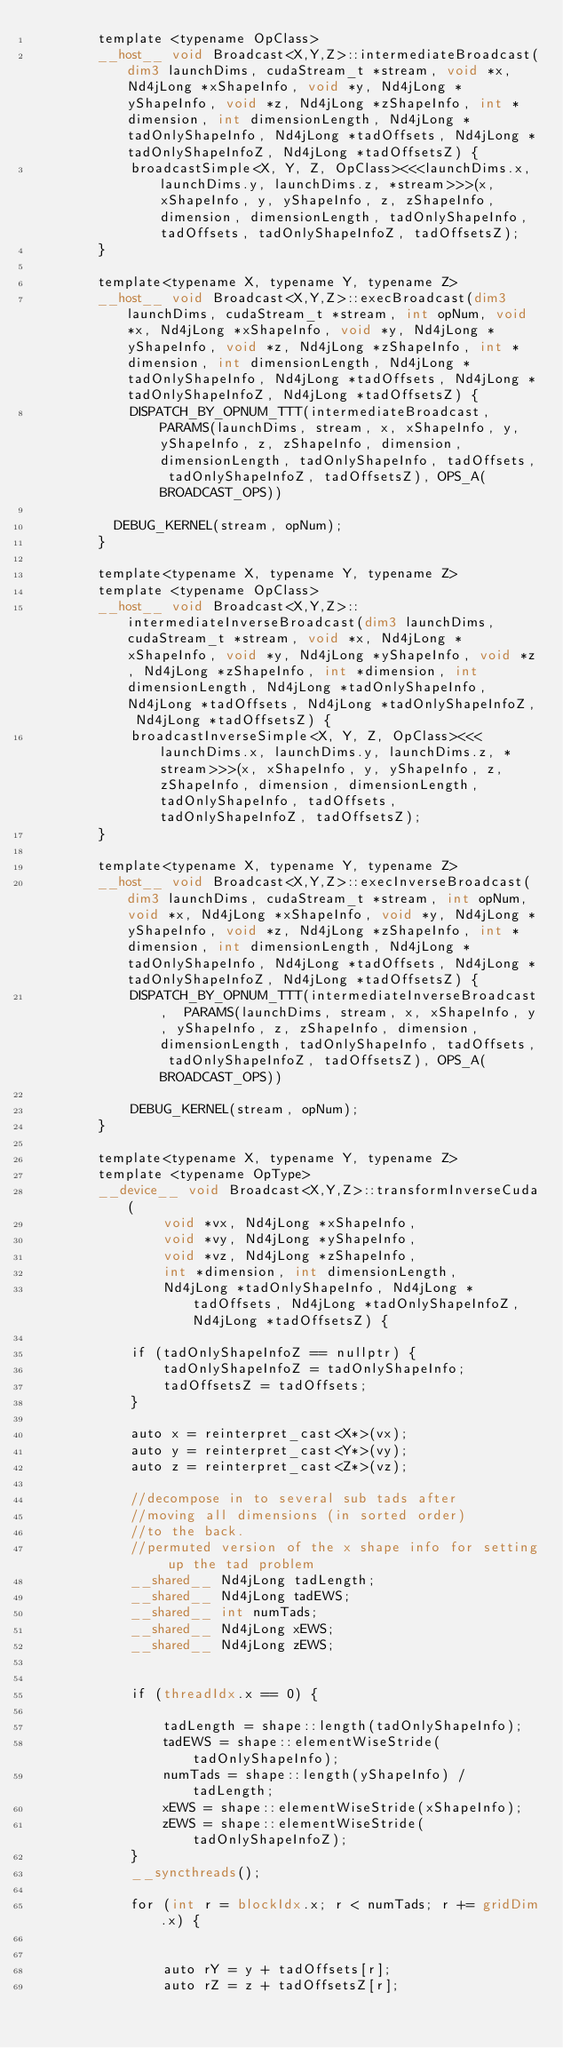<code> <loc_0><loc_0><loc_500><loc_500><_Cuda_>        template <typename OpClass>
        __host__ void Broadcast<X,Y,Z>::intermediateBroadcast(dim3 launchDims, cudaStream_t *stream, void *x, Nd4jLong *xShapeInfo, void *y, Nd4jLong *yShapeInfo, void *z, Nd4jLong *zShapeInfo, int *dimension, int dimensionLength, Nd4jLong *tadOnlyShapeInfo, Nd4jLong *tadOffsets, Nd4jLong *tadOnlyShapeInfoZ, Nd4jLong *tadOffsetsZ) {
            broadcastSimple<X, Y, Z, OpClass><<<launchDims.x, launchDims.y, launchDims.z, *stream>>>(x, xShapeInfo, y, yShapeInfo, z, zShapeInfo, dimension, dimensionLength, tadOnlyShapeInfo, tadOffsets, tadOnlyShapeInfoZ, tadOffsetsZ);
        }

        template<typename X, typename Y, typename Z>
        __host__ void Broadcast<X,Y,Z>::execBroadcast(dim3 launchDims, cudaStream_t *stream, int opNum, void *x, Nd4jLong *xShapeInfo, void *y, Nd4jLong *yShapeInfo, void *z, Nd4jLong *zShapeInfo, int *dimension, int dimensionLength, Nd4jLong *tadOnlyShapeInfo, Nd4jLong *tadOffsets, Nd4jLong *tadOnlyShapeInfoZ, Nd4jLong *tadOffsetsZ) {
            DISPATCH_BY_OPNUM_TTT(intermediateBroadcast,  PARAMS(launchDims, stream, x, xShapeInfo, y, yShapeInfo, z, zShapeInfo, dimension, dimensionLength, tadOnlyShapeInfo, tadOffsets, tadOnlyShapeInfoZ, tadOffsetsZ), OPS_A(BROADCAST_OPS))

	        DEBUG_KERNEL(stream, opNum);
        }

        template<typename X, typename Y, typename Z>
        template <typename OpClass>
        __host__ void Broadcast<X,Y,Z>::intermediateInverseBroadcast(dim3 launchDims, cudaStream_t *stream, void *x, Nd4jLong *xShapeInfo, void *y, Nd4jLong *yShapeInfo, void *z, Nd4jLong *zShapeInfo, int *dimension, int dimensionLength, Nd4jLong *tadOnlyShapeInfo, Nd4jLong *tadOffsets, Nd4jLong *tadOnlyShapeInfoZ, Nd4jLong *tadOffsetsZ) {
            broadcastInverseSimple<X, Y, Z, OpClass><<<launchDims.x, launchDims.y, launchDims.z, *stream>>>(x, xShapeInfo, y, yShapeInfo, z, zShapeInfo, dimension, dimensionLength, tadOnlyShapeInfo, tadOffsets, tadOnlyShapeInfoZ, tadOffsetsZ);
        }

        template<typename X, typename Y, typename Z>
        __host__ void Broadcast<X,Y,Z>::execInverseBroadcast(dim3 launchDims, cudaStream_t *stream, int opNum, void *x, Nd4jLong *xShapeInfo, void *y, Nd4jLong *yShapeInfo, void *z, Nd4jLong *zShapeInfo, int *dimension, int dimensionLength, Nd4jLong *tadOnlyShapeInfo, Nd4jLong *tadOffsets, Nd4jLong *tadOnlyShapeInfoZ, Nd4jLong *tadOffsetsZ) {
            DISPATCH_BY_OPNUM_TTT(intermediateInverseBroadcast,  PARAMS(launchDims, stream, x, xShapeInfo, y, yShapeInfo, z, zShapeInfo, dimension, dimensionLength, tadOnlyShapeInfo, tadOffsets, tadOnlyShapeInfoZ, tadOffsetsZ), OPS_A(BROADCAST_OPS))

            DEBUG_KERNEL(stream, opNum);
        }

        template<typename X, typename Y, typename Z>
        template <typename OpType>
        __device__ void Broadcast<X,Y,Z>::transformInverseCuda(
                void *vx, Nd4jLong *xShapeInfo,
                void *vy, Nd4jLong *yShapeInfo,
                void *vz, Nd4jLong *zShapeInfo,
                int *dimension, int dimensionLength,
                Nd4jLong *tadOnlyShapeInfo, Nd4jLong *tadOffsets, Nd4jLong *tadOnlyShapeInfoZ, Nd4jLong *tadOffsetsZ) {

            if (tadOnlyShapeInfoZ == nullptr) {
                tadOnlyShapeInfoZ = tadOnlyShapeInfo;
                tadOffsetsZ = tadOffsets;
            }

            auto x = reinterpret_cast<X*>(vx);
            auto y = reinterpret_cast<Y*>(vy);
            auto z = reinterpret_cast<Z*>(vz);

            //decompose in to several sub tads after
            //moving all dimensions (in sorted order)
            //to the back.
            //permuted version of the x shape info for setting up the tad problem
            __shared__ Nd4jLong tadLength;
            __shared__ Nd4jLong tadEWS;
            __shared__ int numTads;
            __shared__ Nd4jLong xEWS;
            __shared__ Nd4jLong zEWS;


            if (threadIdx.x == 0) {

                tadLength = shape::length(tadOnlyShapeInfo);
                tadEWS = shape::elementWiseStride(tadOnlyShapeInfo);
                numTads = shape::length(yShapeInfo) / tadLength;
                xEWS = shape::elementWiseStride(xShapeInfo);
                zEWS = shape::elementWiseStride(tadOnlyShapeInfoZ);
            }
            __syncthreads();

            for (int r = blockIdx.x; r < numTads; r += gridDim.x) {


                auto rY = y + tadOffsets[r];
                auto rZ = z + tadOffsetsZ[r];

</code> 